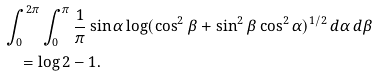Convert formula to latex. <formula><loc_0><loc_0><loc_500><loc_500>& \int _ { 0 } ^ { 2 \pi } \int _ { 0 } ^ { \pi } \frac { 1 } { \pi } \sin \alpha \log ( \cos ^ { 2 } \beta + \sin ^ { 2 } \beta \cos ^ { 2 } \alpha ) ^ { 1 / 2 } \, d \alpha \, d \beta \\ & \quad = \log 2 - 1 .</formula> 